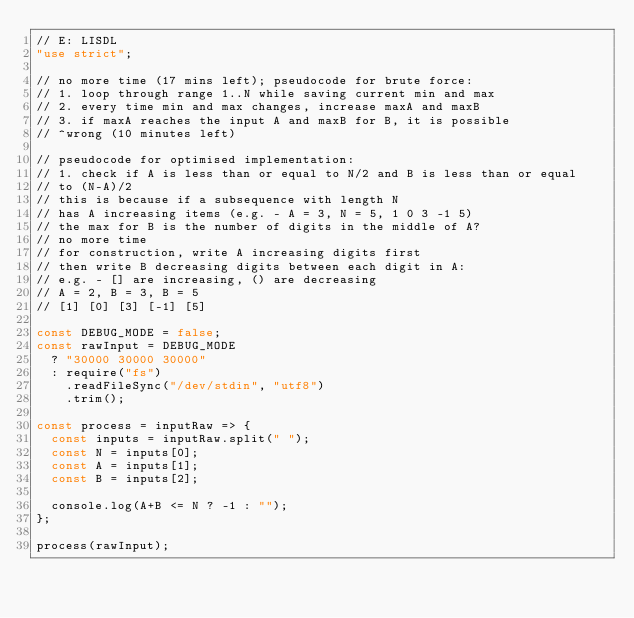<code> <loc_0><loc_0><loc_500><loc_500><_JavaScript_>// E: LISDL
"use strict";

// no more time (17 mins left); pseudocode for brute force:
// 1. loop through range 1..N while saving current min and max
// 2. every time min and max changes, increase maxA and maxB
// 3. if maxA reaches the input A and maxB for B, it is possible
// ^wrong (10 minutes left)

// pseudocode for optimised implementation:
// 1. check if A is less than or equal to N/2 and B is less than or equal
// to (N-A)/2
// this is because if a subsequence with length N
// has A increasing items (e.g. - A = 3, N = 5, 1 0 3 -1 5)
// the max for B is the number of digits in the middle of A?
// no more time
// for construction, write A increasing digits first
// then write B decreasing digits between each digit in A:
// e.g. - [] are increasing, () are decreasing
// A = 2, B = 3, B = 5
// [1] [0] [3] [-1] [5]

const DEBUG_MODE = false;
const rawInput = DEBUG_MODE
  ? "30000 30000 30000"
  : require("fs")
    .readFileSync("/dev/stdin", "utf8")
    .trim();

const process = inputRaw => {
  const inputs = inputRaw.split(" ");
  const N = inputs[0];
  const A = inputs[1];
  const B = inputs[2];

  console.log(A+B <= N ? -1 : "");
};

process(rawInput);
</code> 